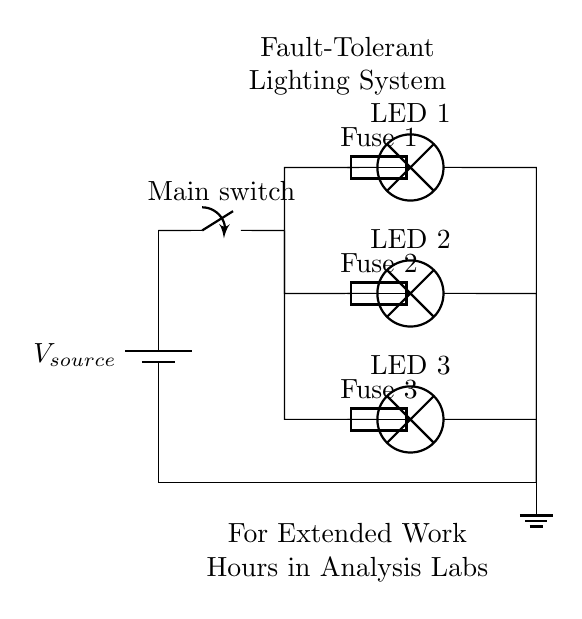What is the power source type in this circuit? The power source is a battery, as indicated by the battery symbol in the circuit diagram.
Answer: battery How many lamps are connected in parallel? There are three lamps connected in parallel, as shown by the branching connections leading from the same point.
Answer: three What is the purpose of the fuses in this circuit? The fuses serve as safety devices to protect each lamp from overcurrent and potential damage by breaking the circuit if the current exceeds safe levels.
Answer: safety How does the failure of one lamp affect the others in this circuit? In a parallel circuit, if one lamp fails, it does not interrupt the current flow to the other lamps, allowing them to continue functioning.
Answer: continues functioning What is the advantage of using parallel circuits for extended work hours? The advantage is that parallel circuits allow multiple components to operate independently, ensuring continued operation during extended work hours even if one branch fails.
Answer: continued operation 